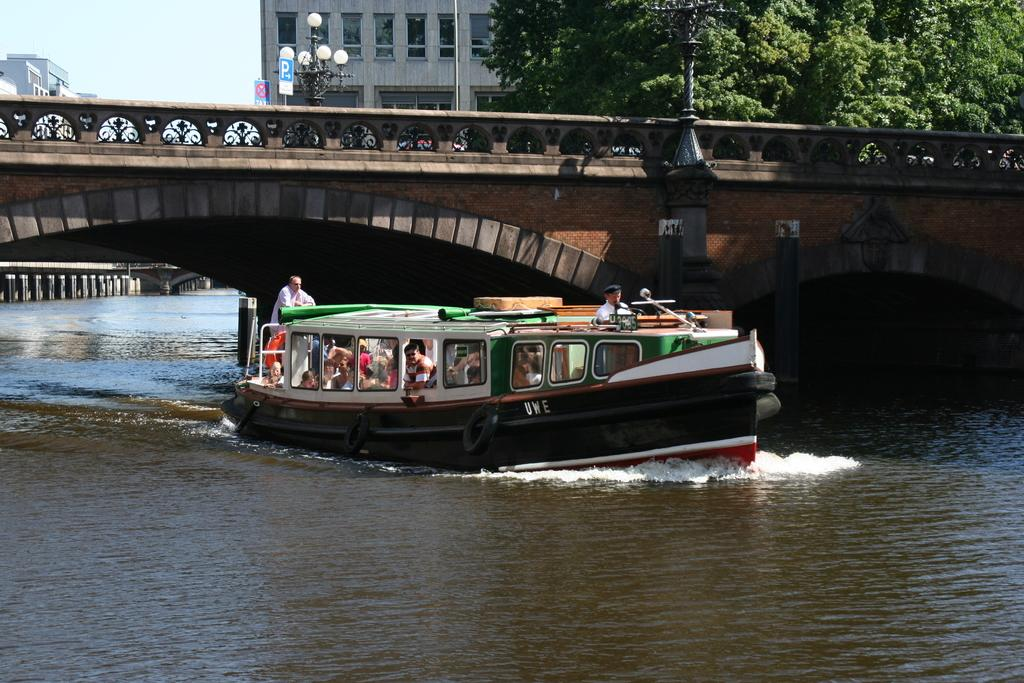What is the main subject of the image? The main subject of the image is a boat. Are there any people in the boat? Yes, there are people in the boat. Where is the boat located? The boat is on the water. What is above the boat in the image? There is a bridge above the boat. What can be seen in the background of the image? There are buildings and trees in the background of the image. What type of drug can be seen in the hands of the people on the boat? There is no drug present in the image; the people in the boat are not holding any drugs. 